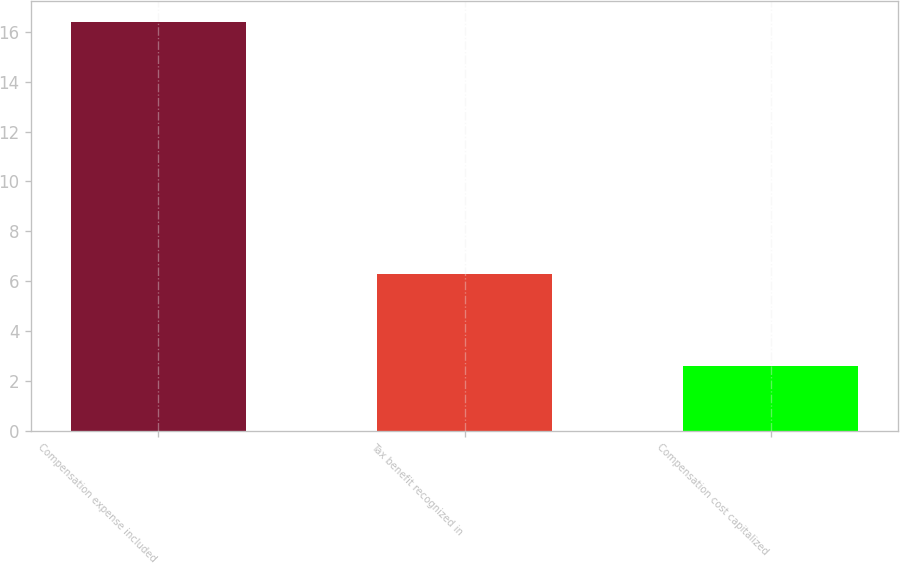<chart> <loc_0><loc_0><loc_500><loc_500><bar_chart><fcel>Compensation expense included<fcel>Tax benefit recognized in<fcel>Compensation cost capitalized<nl><fcel>16.4<fcel>6.3<fcel>2.6<nl></chart> 